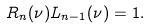Convert formula to latex. <formula><loc_0><loc_0><loc_500><loc_500>R _ { n } ( \nu ) L _ { n - 1 } ( \nu ) = 1 .</formula> 